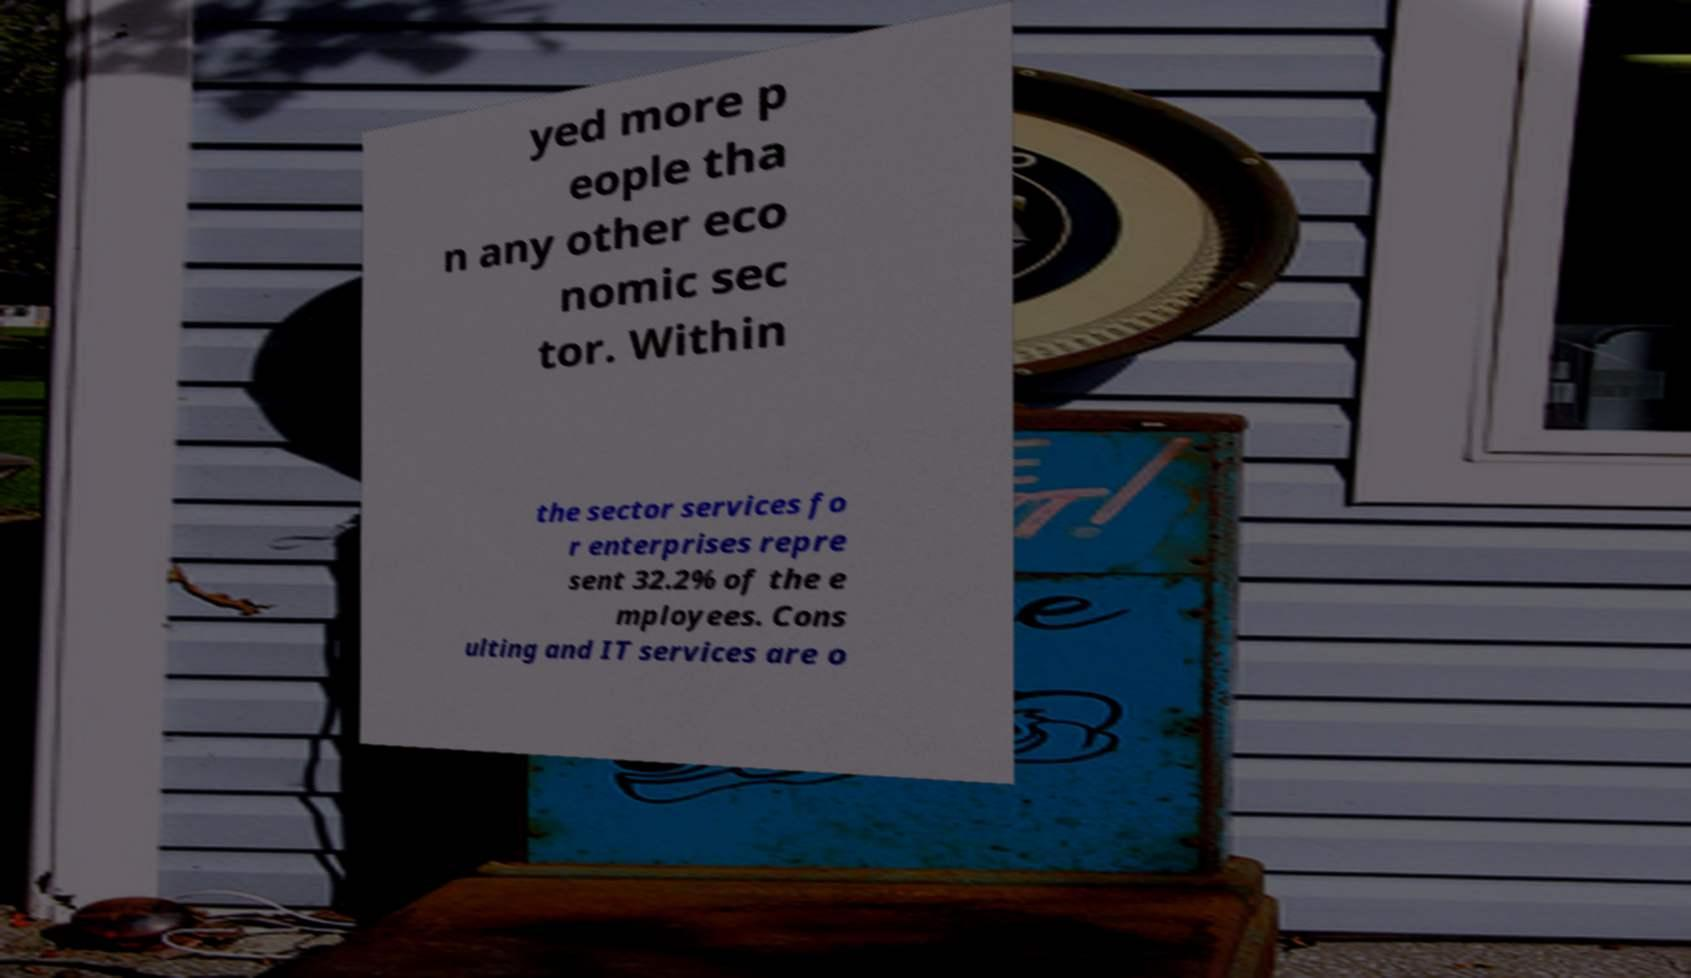Can you read and provide the text displayed in the image?This photo seems to have some interesting text. Can you extract and type it out for me? yed more p eople tha n any other eco nomic sec tor. Within the sector services fo r enterprises repre sent 32.2% of the e mployees. Cons ulting and IT services are o 